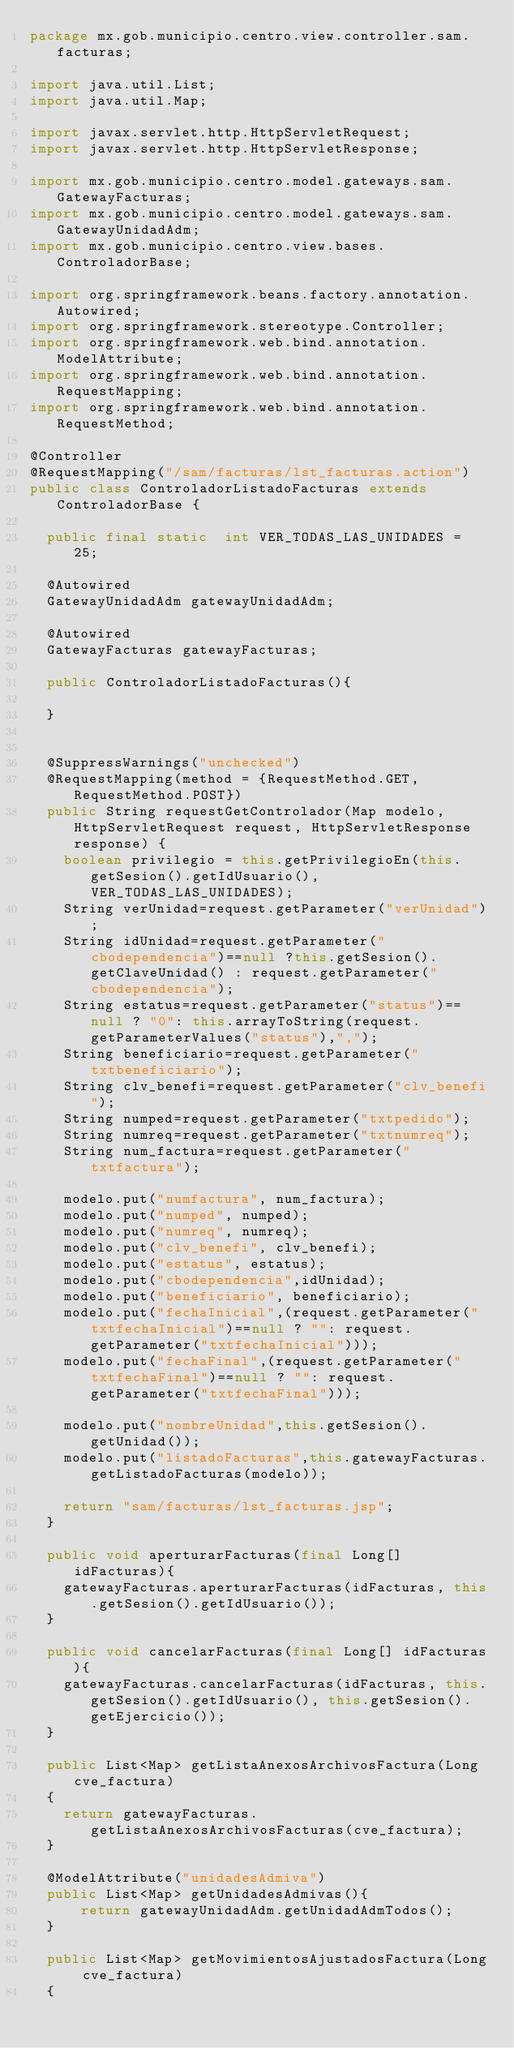Convert code to text. <code><loc_0><loc_0><loc_500><loc_500><_Java_>package mx.gob.municipio.centro.view.controller.sam.facturas;

import java.util.List;
import java.util.Map;

import javax.servlet.http.HttpServletRequest;
import javax.servlet.http.HttpServletResponse;

import mx.gob.municipio.centro.model.gateways.sam.GatewayFacturas;
import mx.gob.municipio.centro.model.gateways.sam.GatewayUnidadAdm;
import mx.gob.municipio.centro.view.bases.ControladorBase;

import org.springframework.beans.factory.annotation.Autowired;
import org.springframework.stereotype.Controller;
import org.springframework.web.bind.annotation.ModelAttribute;
import org.springframework.web.bind.annotation.RequestMapping;
import org.springframework.web.bind.annotation.RequestMethod;

@Controller
@RequestMapping("/sam/facturas/lst_facturas.action")
public class ControladorListadoFacturas extends ControladorBase {

	public final static  int VER_TODAS_LAS_UNIDADES = 25;
	
	@Autowired
	GatewayUnidadAdm gatewayUnidadAdm;
	
	@Autowired 
	GatewayFacturas gatewayFacturas;
	
	public ControladorListadoFacturas(){
		
	}
	
	
	@SuppressWarnings("unchecked")
	@RequestMapping(method = {RequestMethod.GET, RequestMethod.POST})  
	public String requestGetControlador(Map modelo, HttpServletRequest request, HttpServletResponse response) {
		boolean privilegio = this.getPrivilegioEn(this.getSesion().getIdUsuario(), VER_TODAS_LAS_UNIDADES);
		String verUnidad=request.getParameter("verUnidad");
		String idUnidad=request.getParameter("cbodependencia")==null ?this.getSesion().getClaveUnidad() : request.getParameter("cbodependencia");
		String estatus=request.getParameter("status")==null ? "0": this.arrayToString(request.getParameterValues("status"),",");
		String beneficiario=request.getParameter("txtbeneficiario");
		String clv_benefi=request.getParameter("clv_benefi");
		String numped=request.getParameter("txtpedido");
		String numreq=request.getParameter("txtnumreq");
		String num_factura=request.getParameter("txtfactura");
		
		modelo.put("numfactura", num_factura);
		modelo.put("numped", numped);
		modelo.put("numreq", numreq);
		modelo.put("clv_benefi", clv_benefi);
		modelo.put("estatus", estatus);
		modelo.put("cbodependencia",idUnidad);
		modelo.put("beneficiario", beneficiario);
		modelo.put("fechaInicial",(request.getParameter("txtfechaInicial")==null ? "": request.getParameter("txtfechaInicial")));
		modelo.put("fechaFinal",(request.getParameter("txtfechaFinal")==null ? "": request.getParameter("txtfechaFinal")));
		
		modelo.put("nombreUnidad",this.getSesion().getUnidad());
		modelo.put("listadoFacturas",this.gatewayFacturas.getListadoFacturas(modelo));
		
		return "sam/facturas/lst_facturas.jsp";
	}
	
	public void aperturarFacturas(final Long[] idFacturas){
		gatewayFacturas.aperturarFacturas(idFacturas, this.getSesion().getIdUsuario());
	}
	
	public void cancelarFacturas(final Long[] idFacturas){
		gatewayFacturas.cancelarFacturas(idFacturas, this.getSesion().getIdUsuario(), this.getSesion().getEjercicio());
	}
	
	public List<Map> getListaAnexosArchivosFactura(Long cve_factura)
	{
		return gatewayFacturas.getListaAnexosArchivosFacturas(cve_factura);
	}
	
	@ModelAttribute("unidadesAdmiva")
	public List<Map> getUnidadesAdmivas(){
	   	return gatewayUnidadAdm.getUnidadAdmTodos();	
	}
	
	public List<Map> getMovimientosAjustadosFactura(Long cve_factura)
	{</code> 